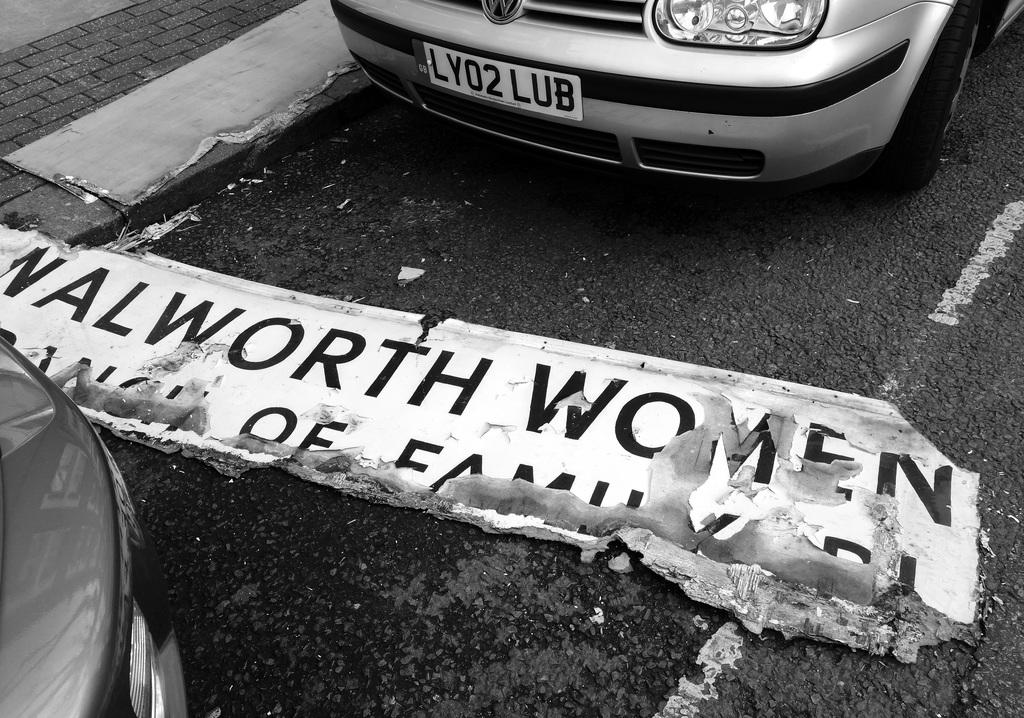<image>
Provide a brief description of the given image. A Walworth Women sign lays on the road between two vehicles. 